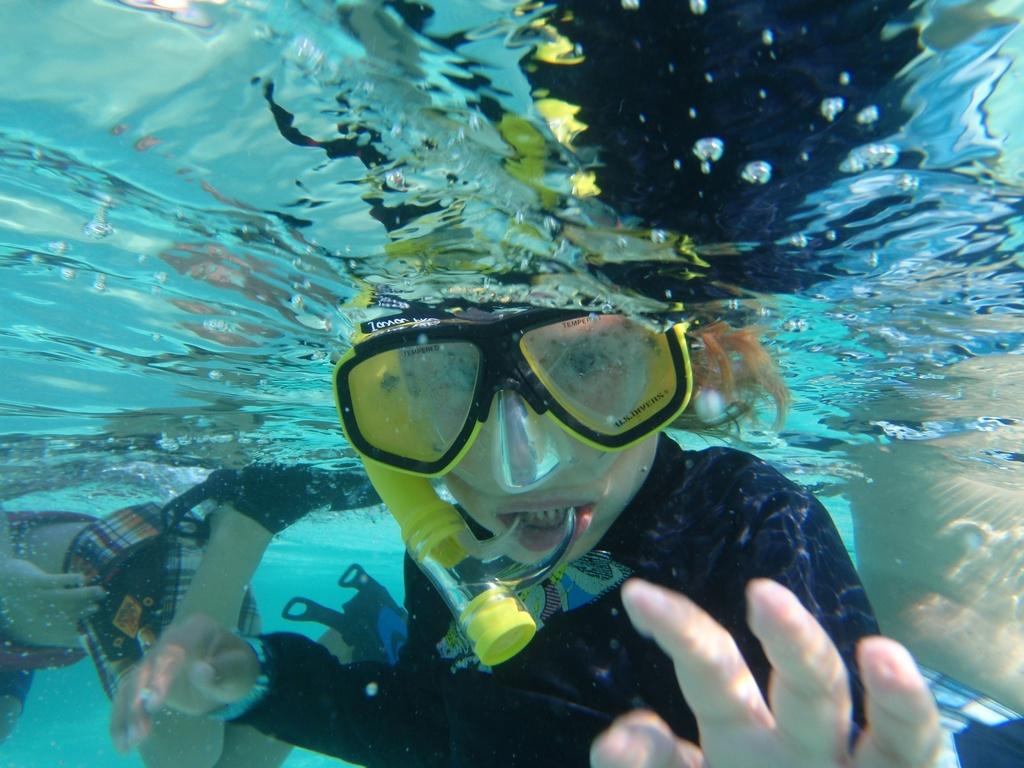What are the people in the image doing? The people in the image are in the water. Can you describe any specific features of one of the people? One person is wearing goggles. What is the person with goggles holding in their mouth? The person with goggles has a pipe in their mouth. What type of pleasure can be seen being sorted by a string in the image? There is no pleasure, sorting, or string present in the image. 